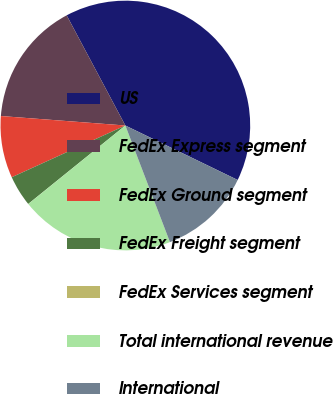Convert chart to OTSL. <chart><loc_0><loc_0><loc_500><loc_500><pie_chart><fcel>US<fcel>FedEx Express segment<fcel>FedEx Ground segment<fcel>FedEx Freight segment<fcel>FedEx Services segment<fcel>Total international revenue<fcel>International<nl><fcel>39.97%<fcel>16.0%<fcel>8.01%<fcel>4.01%<fcel>0.01%<fcel>19.99%<fcel>12.0%<nl></chart> 